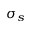Convert formula to latex. <formula><loc_0><loc_0><loc_500><loc_500>\sigma _ { s }</formula> 